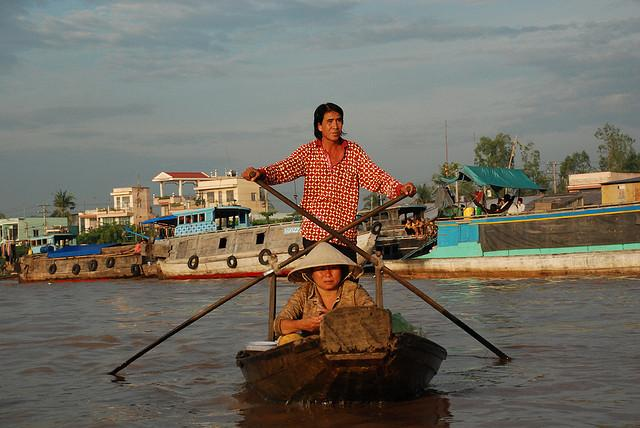The person in the front of the boat is wearing a hat from which continent? asia 